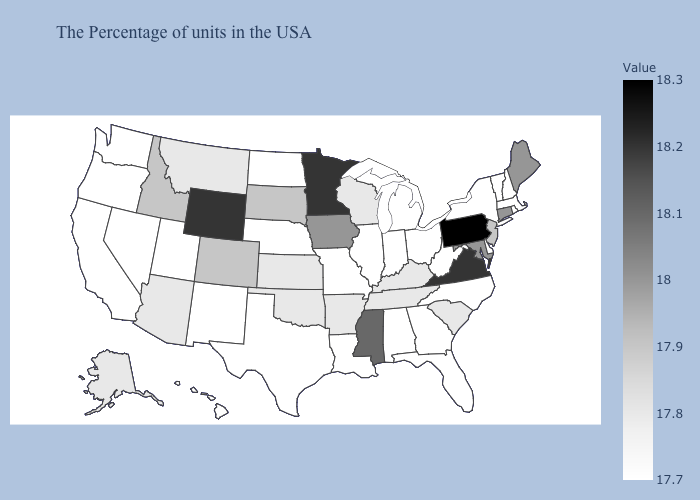Does Oklahoma have a higher value than South Dakota?
Give a very brief answer. No. Does New Jersey have a higher value than Connecticut?
Answer briefly. No. Does Alaska have the highest value in the West?
Give a very brief answer. No. Which states hav the highest value in the MidWest?
Answer briefly. Minnesota. 